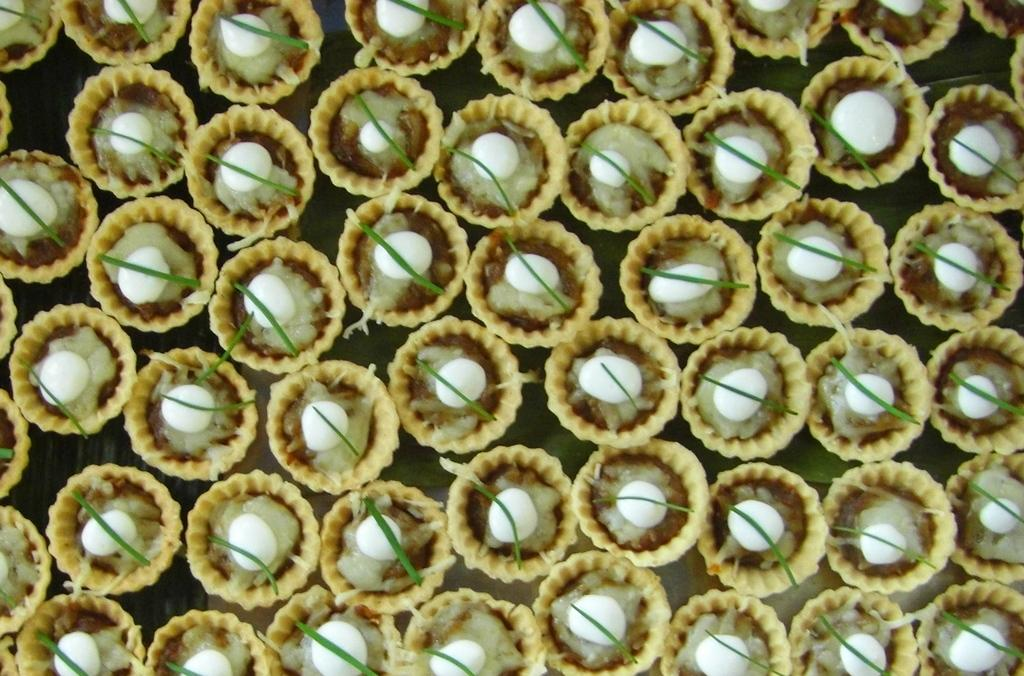What type of food is visible in the image? There are tartlets in the image. What is on top of the tartlets? There is sauce on the tartlets. Are there any other edible items in the image besides the tartlets? Yes, there are other edible items in the image. What book is the person reading in the image? There is no person or book present in the image; it only features tartlets and other edible items. 